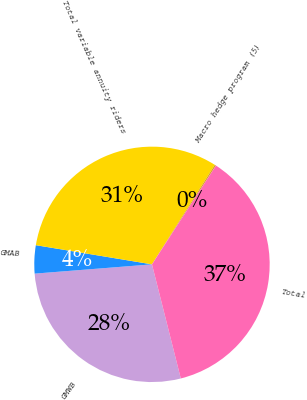Convert chart to OTSL. <chart><loc_0><loc_0><loc_500><loc_500><pie_chart><fcel>GMWB<fcel>GMAB<fcel>Total variable annuity riders<fcel>Macro hedge program (5)<fcel>Total<nl><fcel>27.68%<fcel>3.86%<fcel>31.35%<fcel>0.19%<fcel>36.91%<nl></chart> 